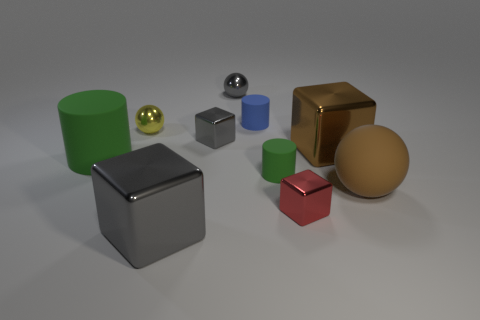What number of other things are the same size as the blue matte object?
Offer a terse response. 5. Does the small yellow shiny object behind the tiny gray shiny cube have the same shape as the green thing behind the tiny green cylinder?
Provide a short and direct response. No. Are there any large brown balls behind the big rubber cylinder?
Make the answer very short. No. What color is the other tiny object that is the same shape as the small green rubber thing?
Make the answer very short. Blue. Are there any other things that are the same shape as the small yellow object?
Offer a very short reply. Yes. There is a blue object that is to the left of the large matte sphere; what material is it?
Ensure brevity in your answer.  Rubber. What is the size of the red thing that is the same shape as the big gray shiny thing?
Provide a succinct answer. Small. How many large brown objects are the same material as the tiny green thing?
Provide a succinct answer. 1. How many large metal cubes have the same color as the large matte ball?
Offer a terse response. 1. What number of objects are cubes that are behind the big brown rubber object or tiny things behind the tiny green cylinder?
Provide a short and direct response. 5. 